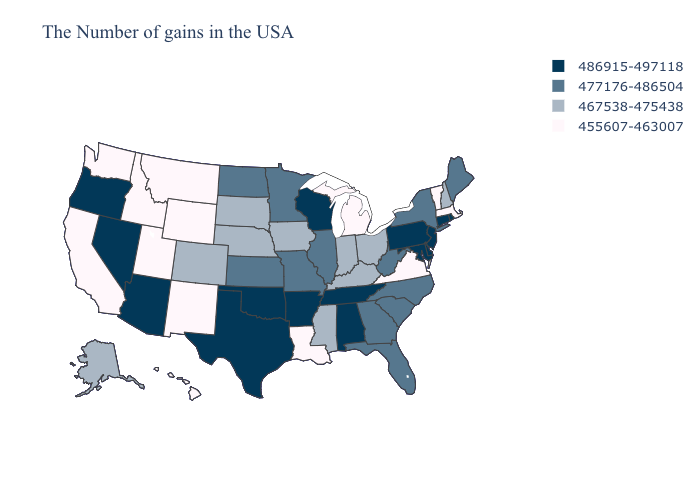What is the lowest value in the West?
Give a very brief answer. 455607-463007. Among the states that border Arizona , which have the highest value?
Concise answer only. Nevada. Does Indiana have the lowest value in the USA?
Keep it brief. No. What is the value of New Jersey?
Keep it brief. 486915-497118. What is the highest value in the Northeast ?
Write a very short answer. 486915-497118. Which states hav the highest value in the South?
Concise answer only. Delaware, Maryland, Alabama, Tennessee, Arkansas, Oklahoma, Texas. What is the value of Missouri?
Concise answer only. 477176-486504. What is the highest value in states that border Iowa?
Be succinct. 486915-497118. Does the map have missing data?
Quick response, please. No. What is the value of Idaho?
Be succinct. 455607-463007. What is the value of California?
Quick response, please. 455607-463007. Name the states that have a value in the range 486915-497118?
Quick response, please. Rhode Island, Connecticut, New Jersey, Delaware, Maryland, Pennsylvania, Alabama, Tennessee, Wisconsin, Arkansas, Oklahoma, Texas, Arizona, Nevada, Oregon. Name the states that have a value in the range 486915-497118?
Quick response, please. Rhode Island, Connecticut, New Jersey, Delaware, Maryland, Pennsylvania, Alabama, Tennessee, Wisconsin, Arkansas, Oklahoma, Texas, Arizona, Nevada, Oregon. Name the states that have a value in the range 455607-463007?
Keep it brief. Massachusetts, Vermont, Virginia, Michigan, Louisiana, Wyoming, New Mexico, Utah, Montana, Idaho, California, Washington, Hawaii. Name the states that have a value in the range 467538-475438?
Give a very brief answer. New Hampshire, Ohio, Kentucky, Indiana, Mississippi, Iowa, Nebraska, South Dakota, Colorado, Alaska. 